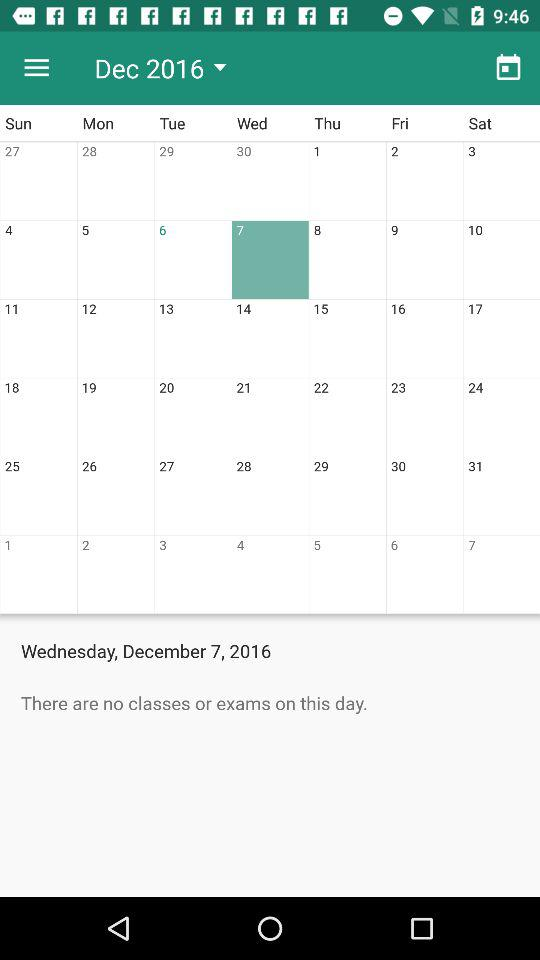Which month is selected? The selected month is December. 